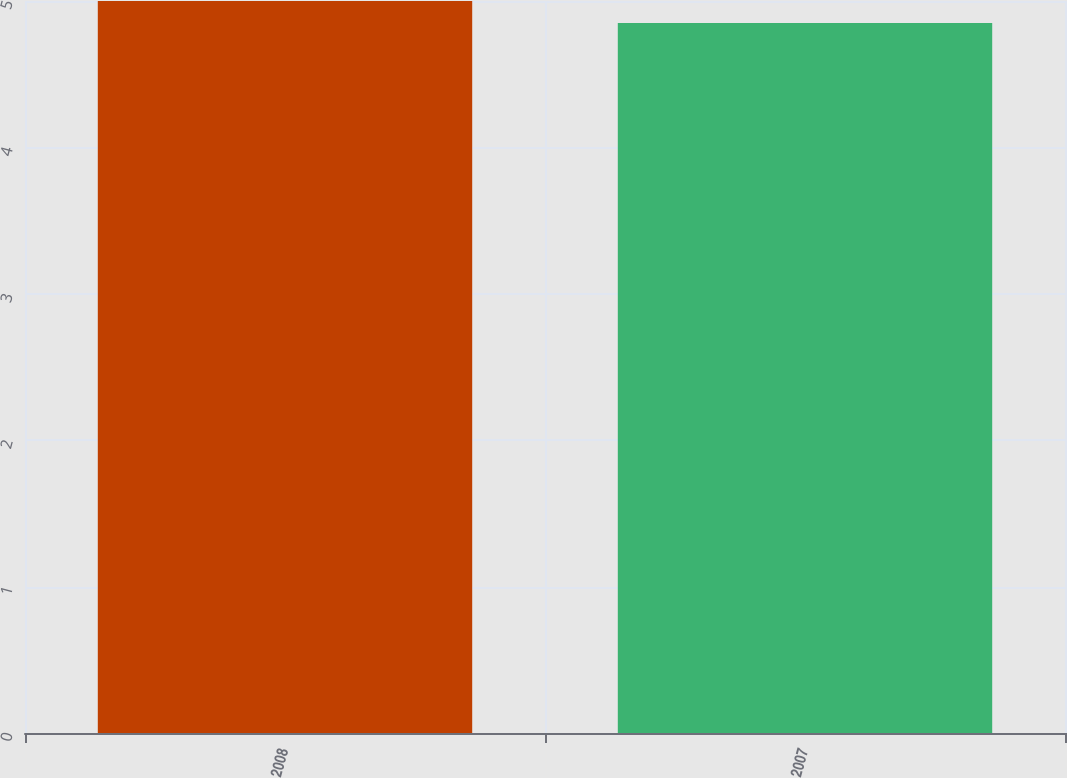<chart> <loc_0><loc_0><loc_500><loc_500><bar_chart><fcel>2008<fcel>2007<nl><fcel>5<fcel>4.85<nl></chart> 